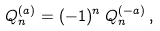Convert formula to latex. <formula><loc_0><loc_0><loc_500><loc_500>Q _ { n } ^ { ( a ) } = ( - 1 ) ^ { n } \, Q _ { n } ^ { ( - a ) } \, ,</formula> 